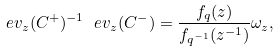Convert formula to latex. <formula><loc_0><loc_0><loc_500><loc_500>\ e v _ { z } ( C ^ { + } ) ^ { - 1 } \ e v _ { z } ( C ^ { - } ) = \frac { f _ { q } ( z ) } { f _ { q ^ { - 1 } } ( z ^ { - 1 } ) } \omega _ { z } ,</formula> 